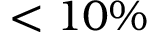Convert formula to latex. <formula><loc_0><loc_0><loc_500><loc_500>\text  less 1 0 \%</formula> 